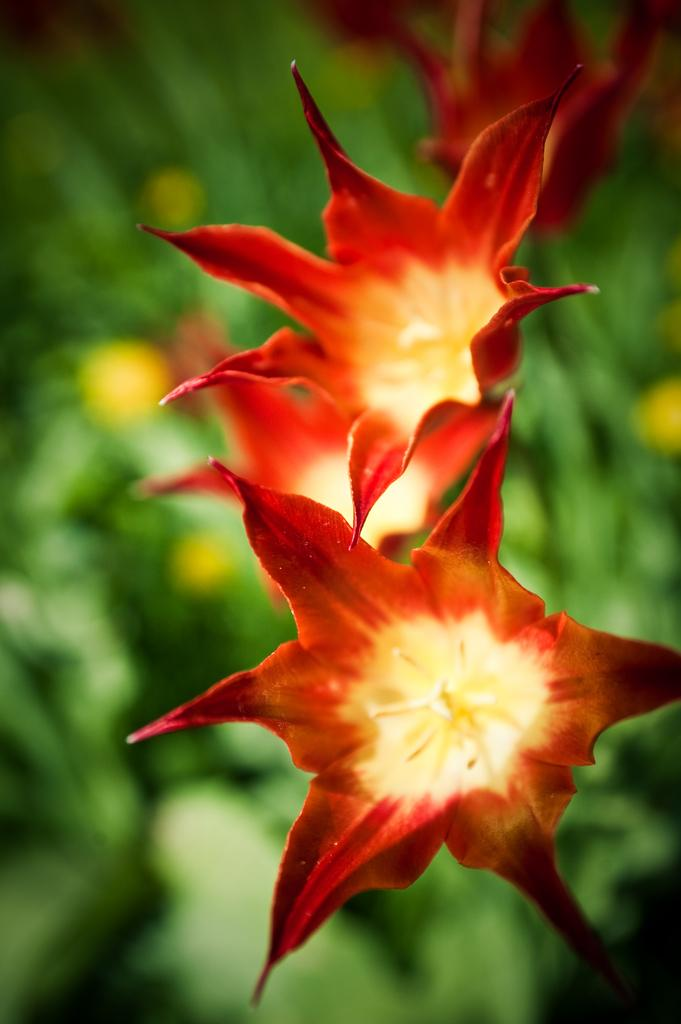What type of living organisms can be seen in the image? There are flowers in the image. Can you describe the background of the image? The background of the image is blurred. What type of suit is the flower wearing in the image? There are no suits or clothing items present in the image, as it features flowers. 